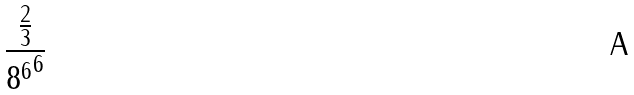Convert formula to latex. <formula><loc_0><loc_0><loc_500><loc_500>\frac { \frac { 2 } { 3 } } { { 8 ^ { 6 } } ^ { 6 } }</formula> 